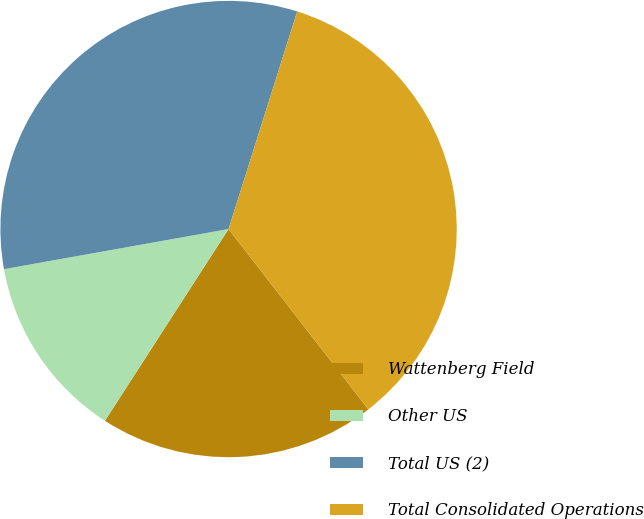Convert chart to OTSL. <chart><loc_0><loc_0><loc_500><loc_500><pie_chart><fcel>Wattenberg Field<fcel>Other US<fcel>Total US (2)<fcel>Total Consolidated Operations<nl><fcel>19.61%<fcel>13.07%<fcel>32.68%<fcel>34.64%<nl></chart> 